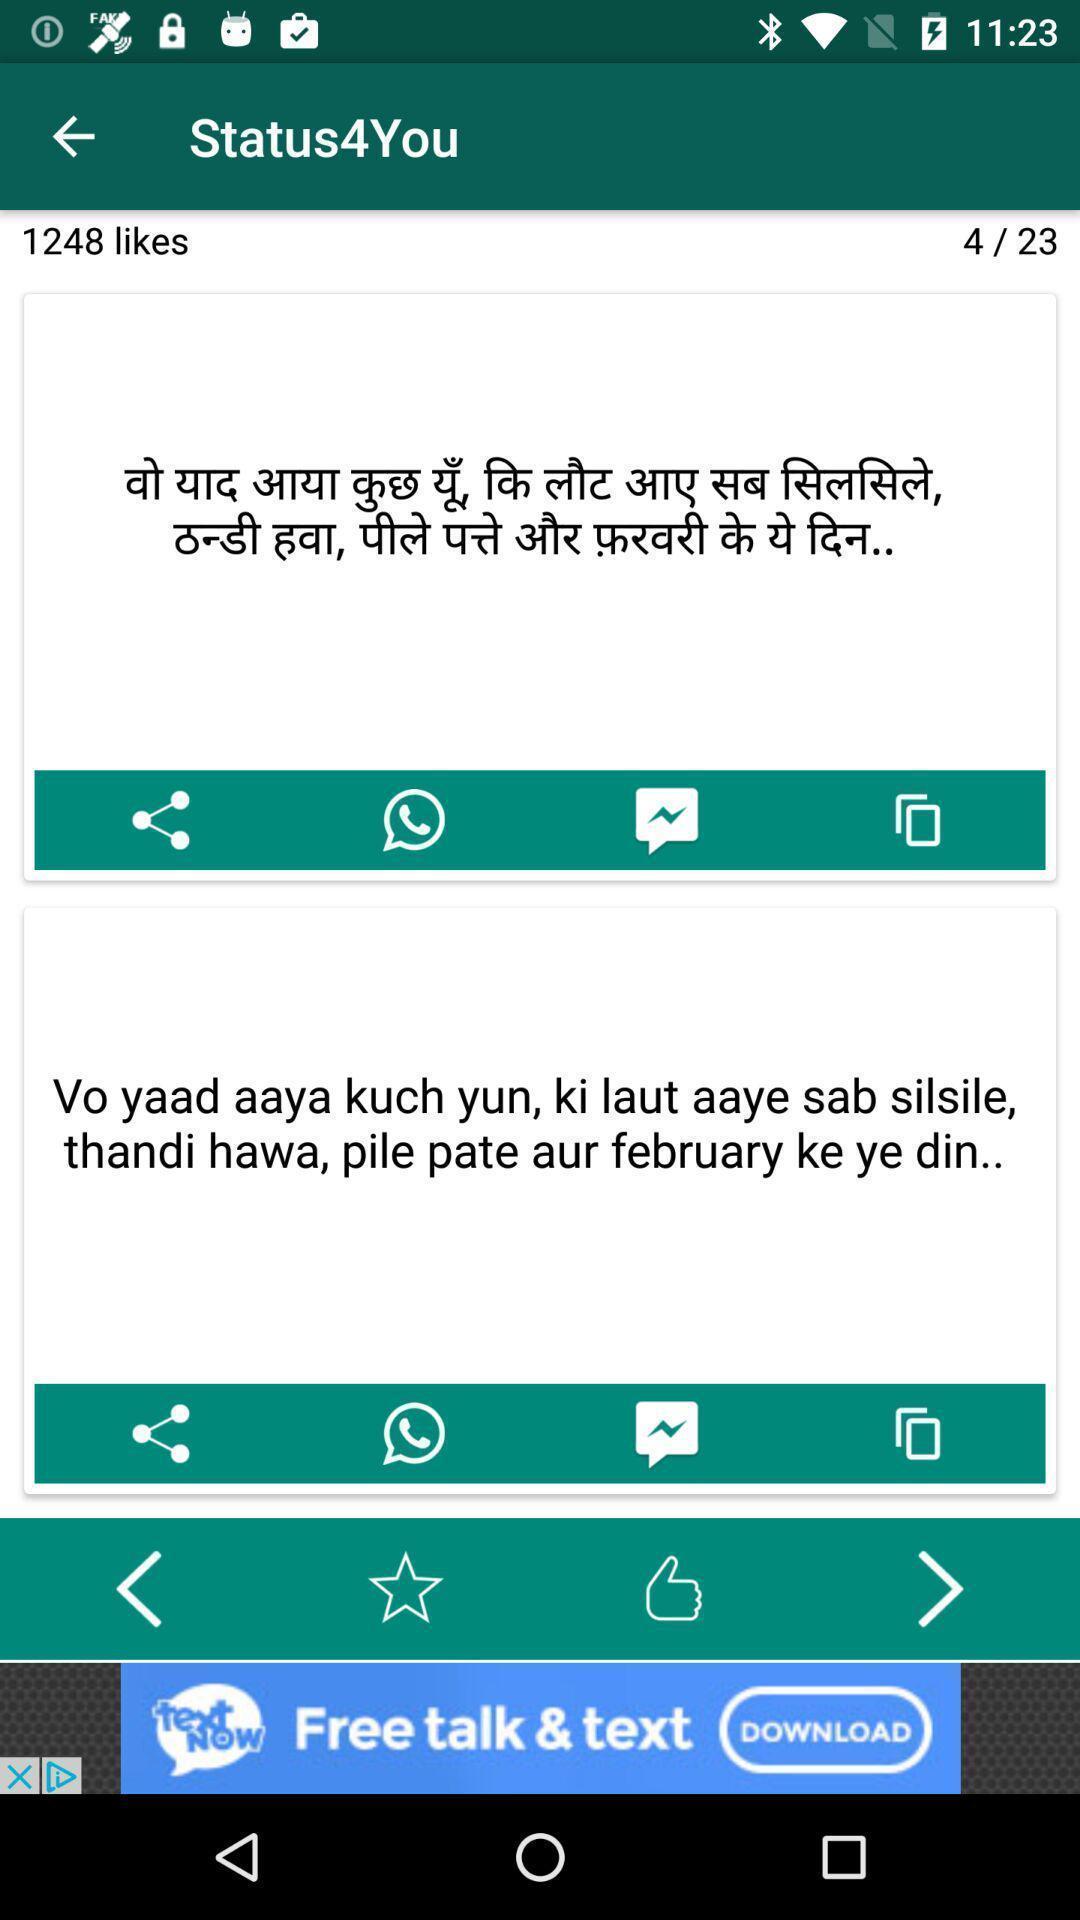Describe the key features of this screenshot. Screen displaying translation result in translator app. 